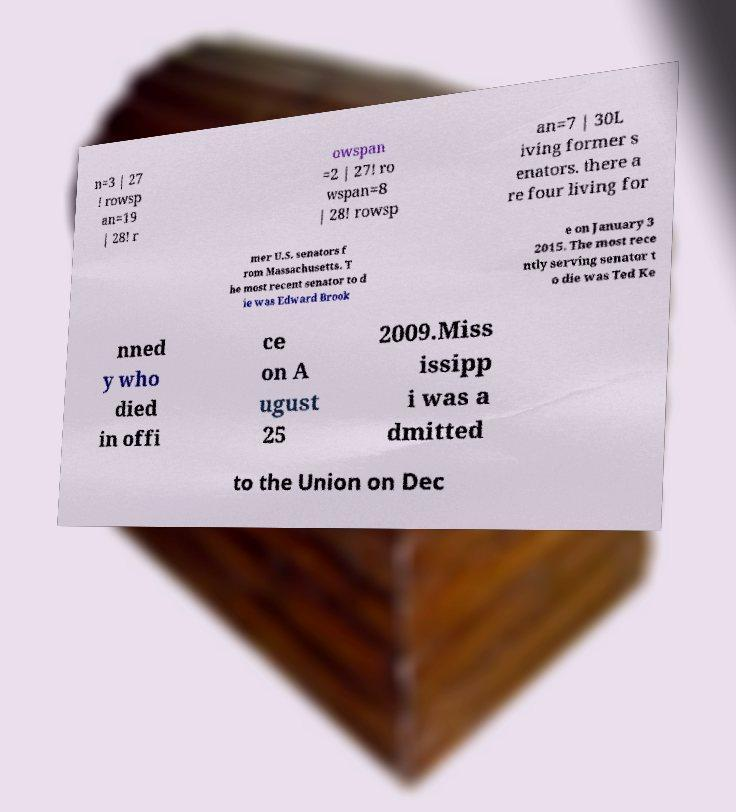For documentation purposes, I need the text within this image transcribed. Could you provide that? n=3 | 27 ! rowsp an=19 | 28! r owspan =2 | 27! ro wspan=8 | 28! rowsp an=7 | 30L iving former s enators. there a re four living for mer U.S. senators f rom Massachusetts. T he most recent senator to d ie was Edward Brook e on January 3 2015. The most rece ntly serving senator t o die was Ted Ke nned y who died in offi ce on A ugust 25 2009.Miss issipp i was a dmitted to the Union on Dec 